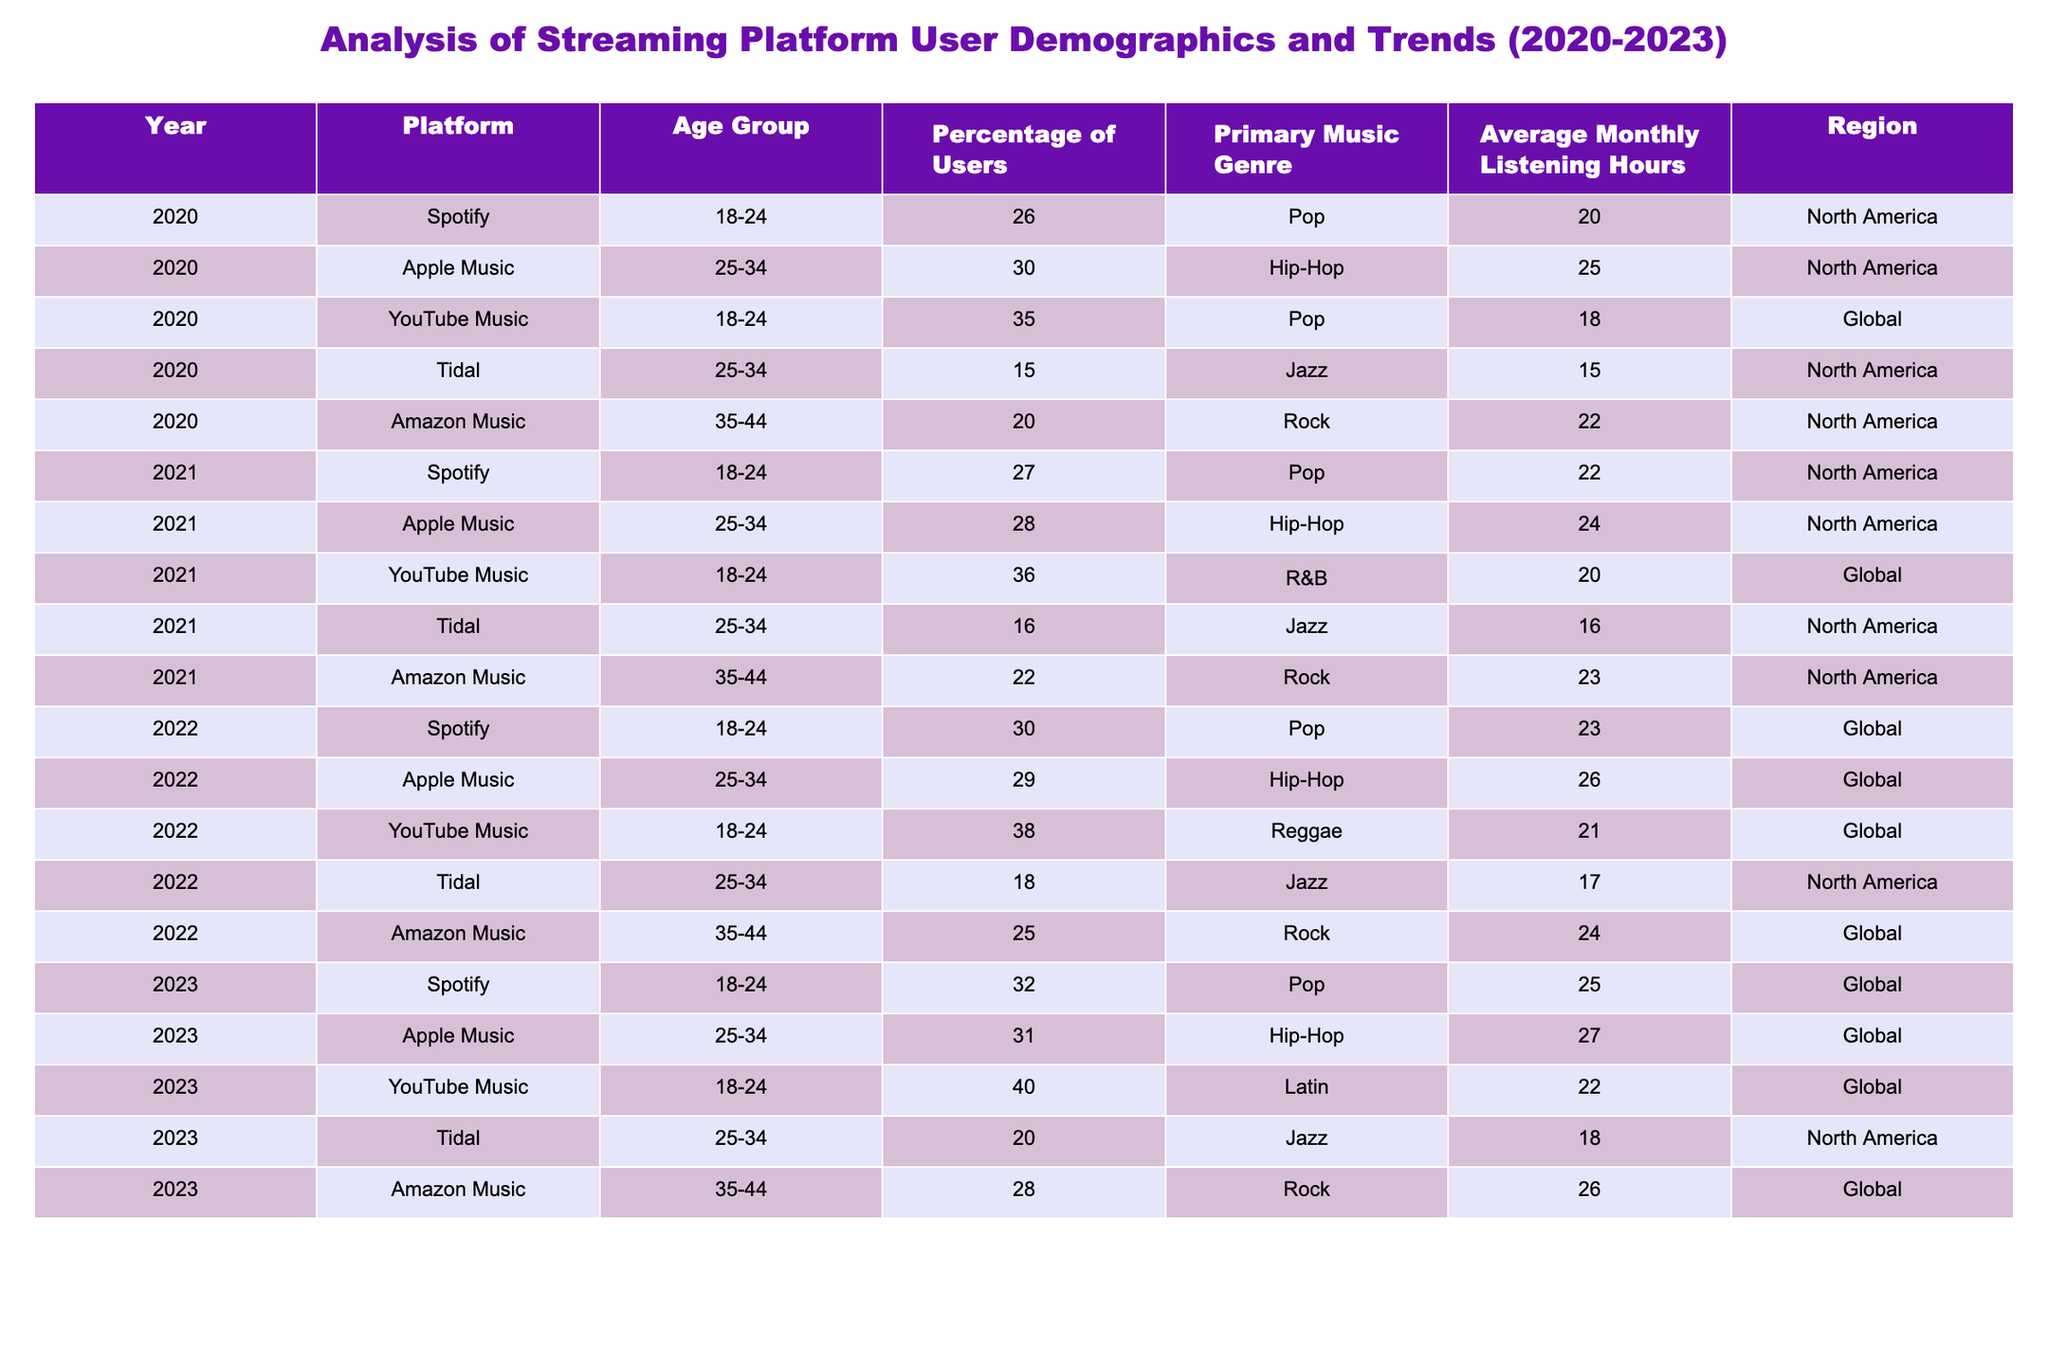What percentage of users aged 25-34 were recorded on Apple Music in 2022? In the row for Apple Music in 2022, the "Age Group" is 25-34 and the "Percentage of Users" is noted as 29%.
Answer: 29% Which platform had the highest percentage of users aged 18-24 in 2023? By checking the rows for the year 2023, Spotify shows 32%, Apple Music shows 31%, and YouTube Music shows 40% for users aged 18-24. YouTube Music has the highest percentage.
Answer: YouTube Music True or False: Tidal had a higher average monthly listening hours in 2021 compared to 2020. In 2021, Tidal had 16 average monthly listening hours while in 2020, it had 15. Since 16 is greater than 15, the statement is true.
Answer: True What is the average percentage of users for the age group 35-44 across all platforms in the year 2022? Summing the percentages from 2022, Amazon Music has 25%. Tidal does not have any, and thus the average is 25% divided by 1, which equals 25%.
Answer: 25% Which music genre was most popular among users aged 18-24 across all platforms in 2022 and what was its percentage? In 2022, the genre for this age group was identified as Reggae on YouTube Music, which had the highest percentage of 38% when compared to other platforms.
Answer: Reggae, 38% True or False: Amazon Music showed an increase in user percentage for the age group 35-44 from 2021 to 2023. In 2021, Amazon Music had 22% for this age group, and in 2023 it was 28%. Since 28% is greater than 22%, the statement is true.
Answer: True What was the primary music genre among users aged 25-34 on Spotify in 2023? The data shows that in 2023, Spotify's primary music genre for the age group 25-34 is Pop.
Answer: Pop What is the total average monthly listening hours for users aged 35-44 across all platforms in 2020? For 2020, the data shows that Amazon Music had 22 hours for this age group, and Tidal had 15 hours. Adding these gives 37 hours, and dividing by 2 (since there are 2 data points) results in an average of 18.5 hours.
Answer: 18.5 hours How did the percentage of users aged 18-24 change from 2020 to 2023 on Spotify? Looking at Spotify in 2020, the percentage was 26%, and in 2023 it rose to 32%. The change is 32% - 26% = 6%, indicating an increase.
Answer: Increased by 6% 